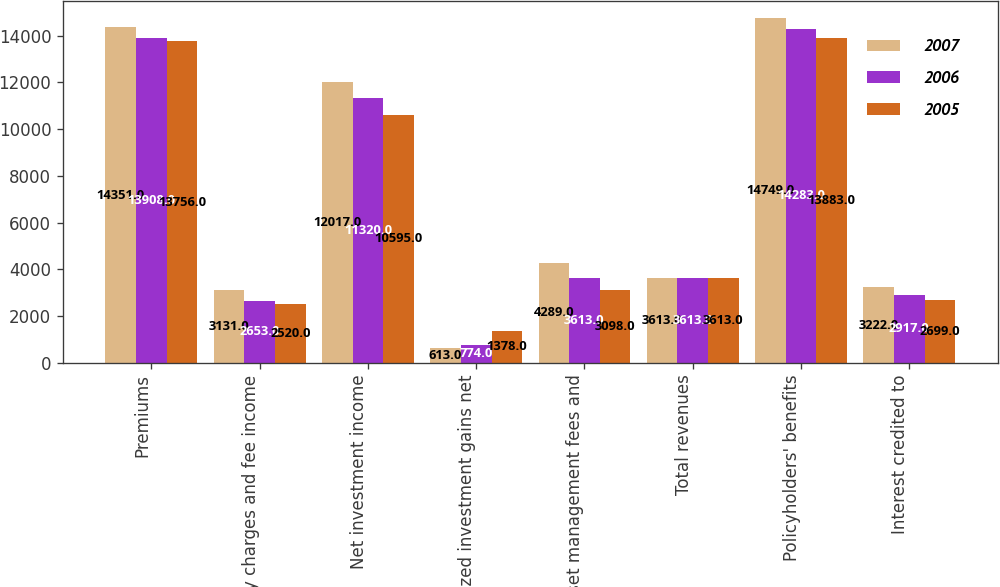<chart> <loc_0><loc_0><loc_500><loc_500><stacked_bar_chart><ecel><fcel>Premiums<fcel>Policy charges and fee income<fcel>Net investment income<fcel>Realized investment gains net<fcel>Asset management fees and<fcel>Total revenues<fcel>Policyholders' benefits<fcel>Interest credited to<nl><fcel>2007<fcel>14351<fcel>3131<fcel>12017<fcel>613<fcel>4289<fcel>3613<fcel>14749<fcel>3222<nl><fcel>2006<fcel>13908<fcel>2653<fcel>11320<fcel>774<fcel>3613<fcel>3613<fcel>14283<fcel>2917<nl><fcel>2005<fcel>13756<fcel>2520<fcel>10595<fcel>1378<fcel>3098<fcel>3613<fcel>13883<fcel>2699<nl></chart> 